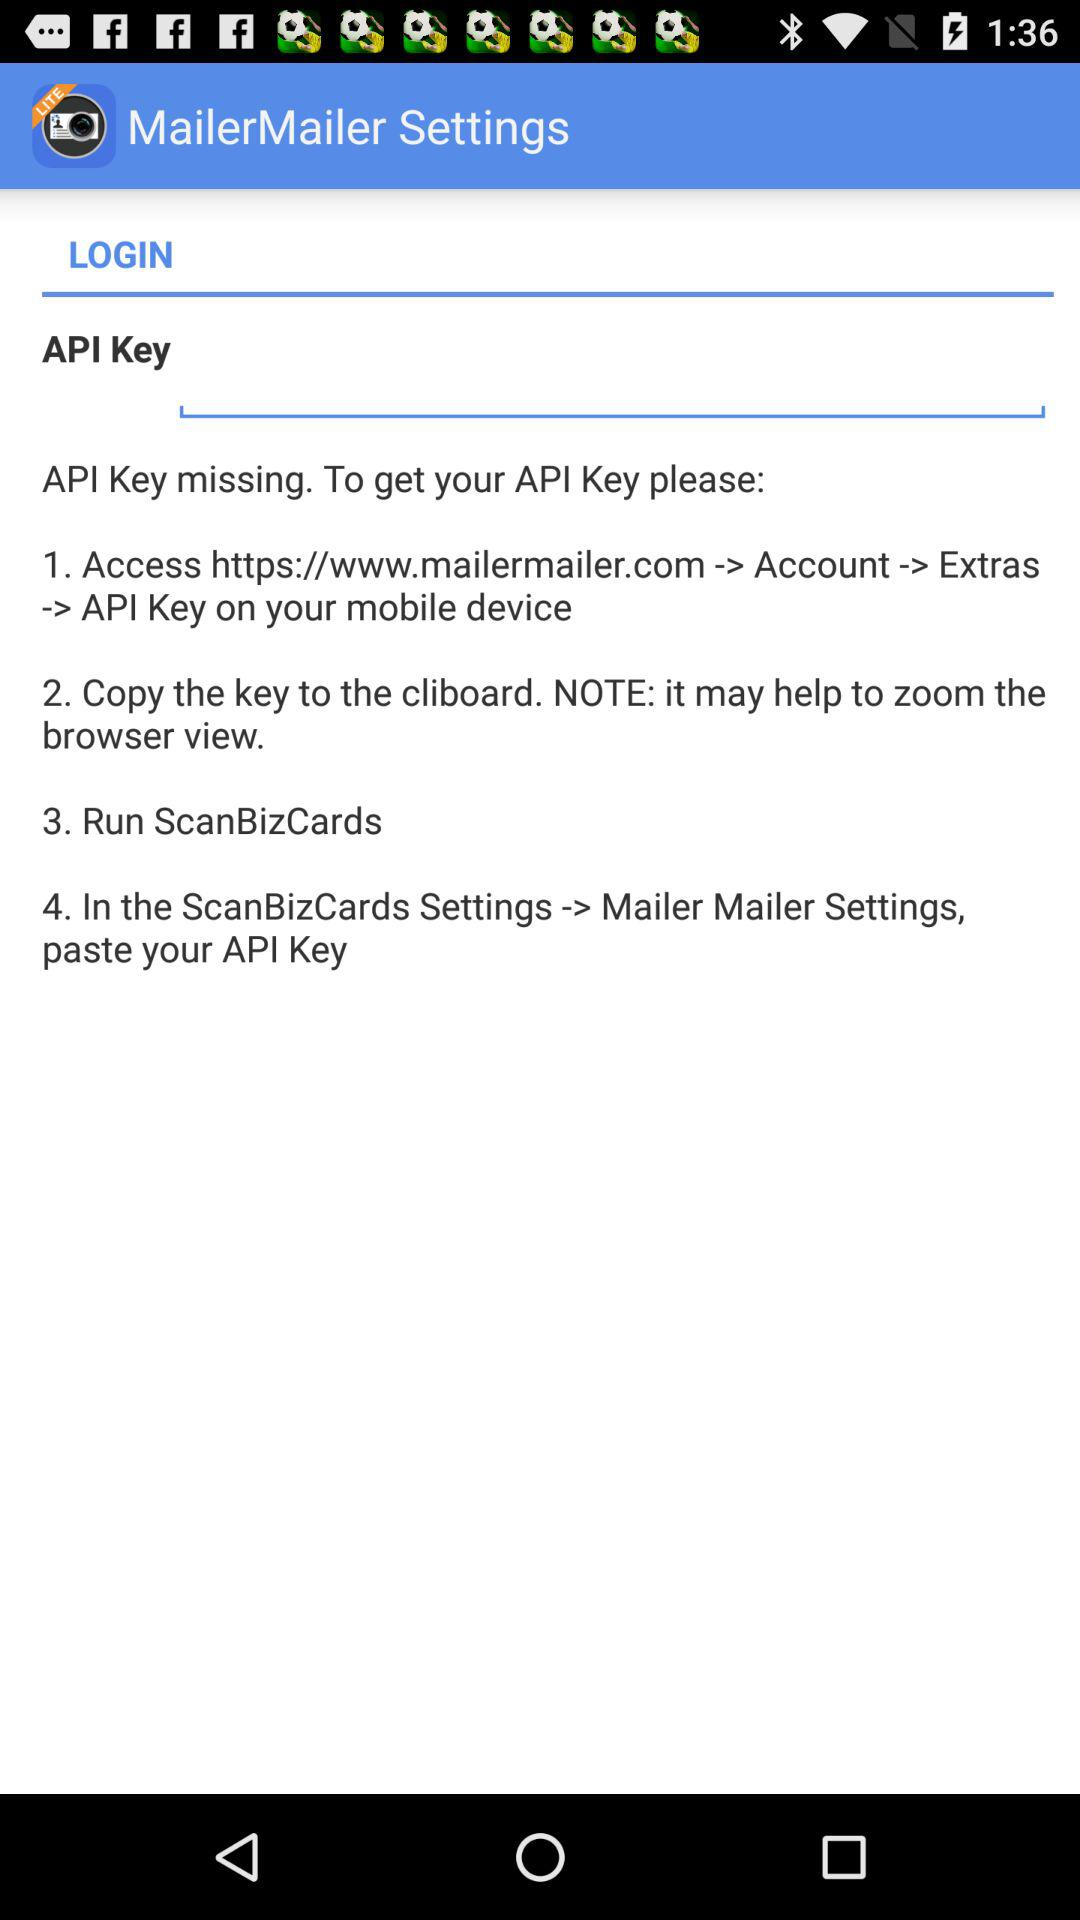What is the application name? The application name is "ScanBizCards Lite". 